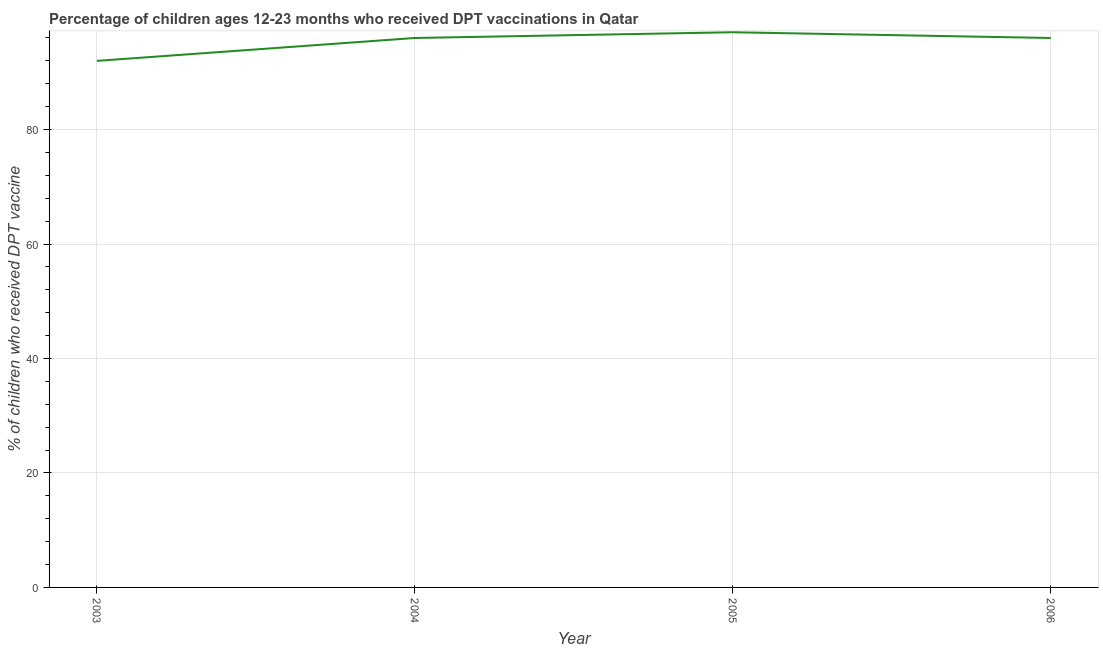What is the percentage of children who received dpt vaccine in 2005?
Your answer should be compact. 97. Across all years, what is the maximum percentage of children who received dpt vaccine?
Make the answer very short. 97. Across all years, what is the minimum percentage of children who received dpt vaccine?
Your answer should be compact. 92. In which year was the percentage of children who received dpt vaccine maximum?
Provide a short and direct response. 2005. What is the sum of the percentage of children who received dpt vaccine?
Keep it short and to the point. 381. What is the difference between the percentage of children who received dpt vaccine in 2003 and 2006?
Provide a succinct answer. -4. What is the average percentage of children who received dpt vaccine per year?
Offer a terse response. 95.25. What is the median percentage of children who received dpt vaccine?
Ensure brevity in your answer.  96. In how many years, is the percentage of children who received dpt vaccine greater than 60 %?
Offer a terse response. 4. What is the ratio of the percentage of children who received dpt vaccine in 2003 to that in 2004?
Offer a terse response. 0.96. Is the percentage of children who received dpt vaccine in 2004 less than that in 2006?
Provide a succinct answer. No. Is the difference between the percentage of children who received dpt vaccine in 2004 and 2005 greater than the difference between any two years?
Ensure brevity in your answer.  No. What is the difference between the highest and the second highest percentage of children who received dpt vaccine?
Keep it short and to the point. 1. What is the difference between the highest and the lowest percentage of children who received dpt vaccine?
Keep it short and to the point. 5. In how many years, is the percentage of children who received dpt vaccine greater than the average percentage of children who received dpt vaccine taken over all years?
Offer a very short reply. 3. Are the values on the major ticks of Y-axis written in scientific E-notation?
Make the answer very short. No. Does the graph contain any zero values?
Provide a succinct answer. No. Does the graph contain grids?
Provide a short and direct response. Yes. What is the title of the graph?
Ensure brevity in your answer.  Percentage of children ages 12-23 months who received DPT vaccinations in Qatar. What is the label or title of the Y-axis?
Keep it short and to the point. % of children who received DPT vaccine. What is the % of children who received DPT vaccine of 2003?
Ensure brevity in your answer.  92. What is the % of children who received DPT vaccine in 2004?
Provide a short and direct response. 96. What is the % of children who received DPT vaccine of 2005?
Offer a very short reply. 97. What is the % of children who received DPT vaccine of 2006?
Provide a succinct answer. 96. What is the difference between the % of children who received DPT vaccine in 2003 and 2004?
Your answer should be compact. -4. What is the difference between the % of children who received DPT vaccine in 2003 and 2005?
Provide a succinct answer. -5. What is the difference between the % of children who received DPT vaccine in 2003 and 2006?
Provide a short and direct response. -4. What is the difference between the % of children who received DPT vaccine in 2005 and 2006?
Provide a succinct answer. 1. What is the ratio of the % of children who received DPT vaccine in 2003 to that in 2004?
Offer a very short reply. 0.96. What is the ratio of the % of children who received DPT vaccine in 2003 to that in 2005?
Your answer should be compact. 0.95. What is the ratio of the % of children who received DPT vaccine in 2003 to that in 2006?
Make the answer very short. 0.96. What is the ratio of the % of children who received DPT vaccine in 2004 to that in 2005?
Give a very brief answer. 0.99. What is the ratio of the % of children who received DPT vaccine in 2004 to that in 2006?
Give a very brief answer. 1. What is the ratio of the % of children who received DPT vaccine in 2005 to that in 2006?
Ensure brevity in your answer.  1.01. 